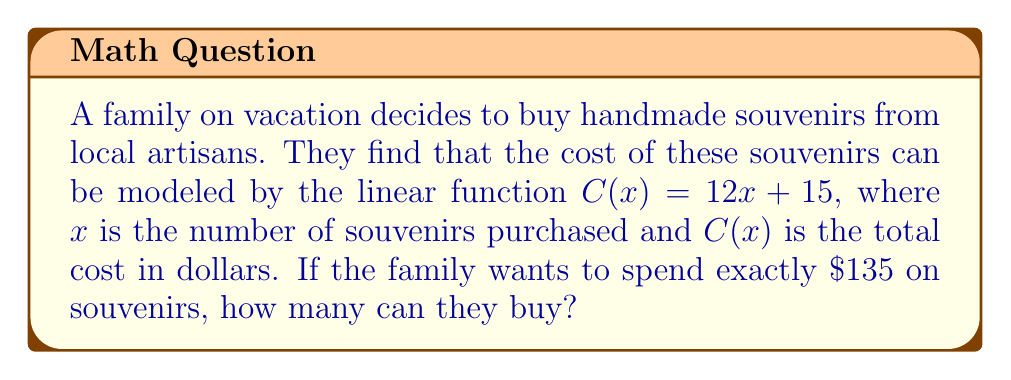What is the answer to this math problem? Let's solve this step-by-step:

1) We're given the linear function $C(x) = 12x + 15$, where:
   $C(x)$ is the total cost in dollars
   $x$ is the number of souvenirs
   12 is the cost per souvenir in dollars
   15 is a fixed cost (perhaps for packaging or a base fee)

2) We want to find $x$ when $C(x) = 135$. So, let's set up the equation:

   $135 = 12x + 15$

3) To solve for $x$, first subtract 15 from both sides:

   $120 = 12x$

4) Now divide both sides by 12:

   $10 = x$

5) Therefore, the family can buy 10 souvenirs for exactly $135.

6) We can verify this by plugging $x = 10$ back into the original function:

   $C(10) = 12(10) + 15 = 120 + 15 = 135$

This confirms our solution is correct.
Answer: 10 souvenirs 